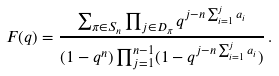Convert formula to latex. <formula><loc_0><loc_0><loc_500><loc_500>F ( q ) & = \frac { \sum _ { \pi \in S _ { n } } \prod _ { j \in D _ { \pi } } q ^ { j - n \sum _ { i = 1 } ^ { j } a _ { i } } } { ( 1 - q ^ { n } ) \prod _ { j = 1 } ^ { n - 1 } ( 1 - q ^ { j - n \sum _ { i = 1 } ^ { j } a _ { i } } ) } \, .</formula> 